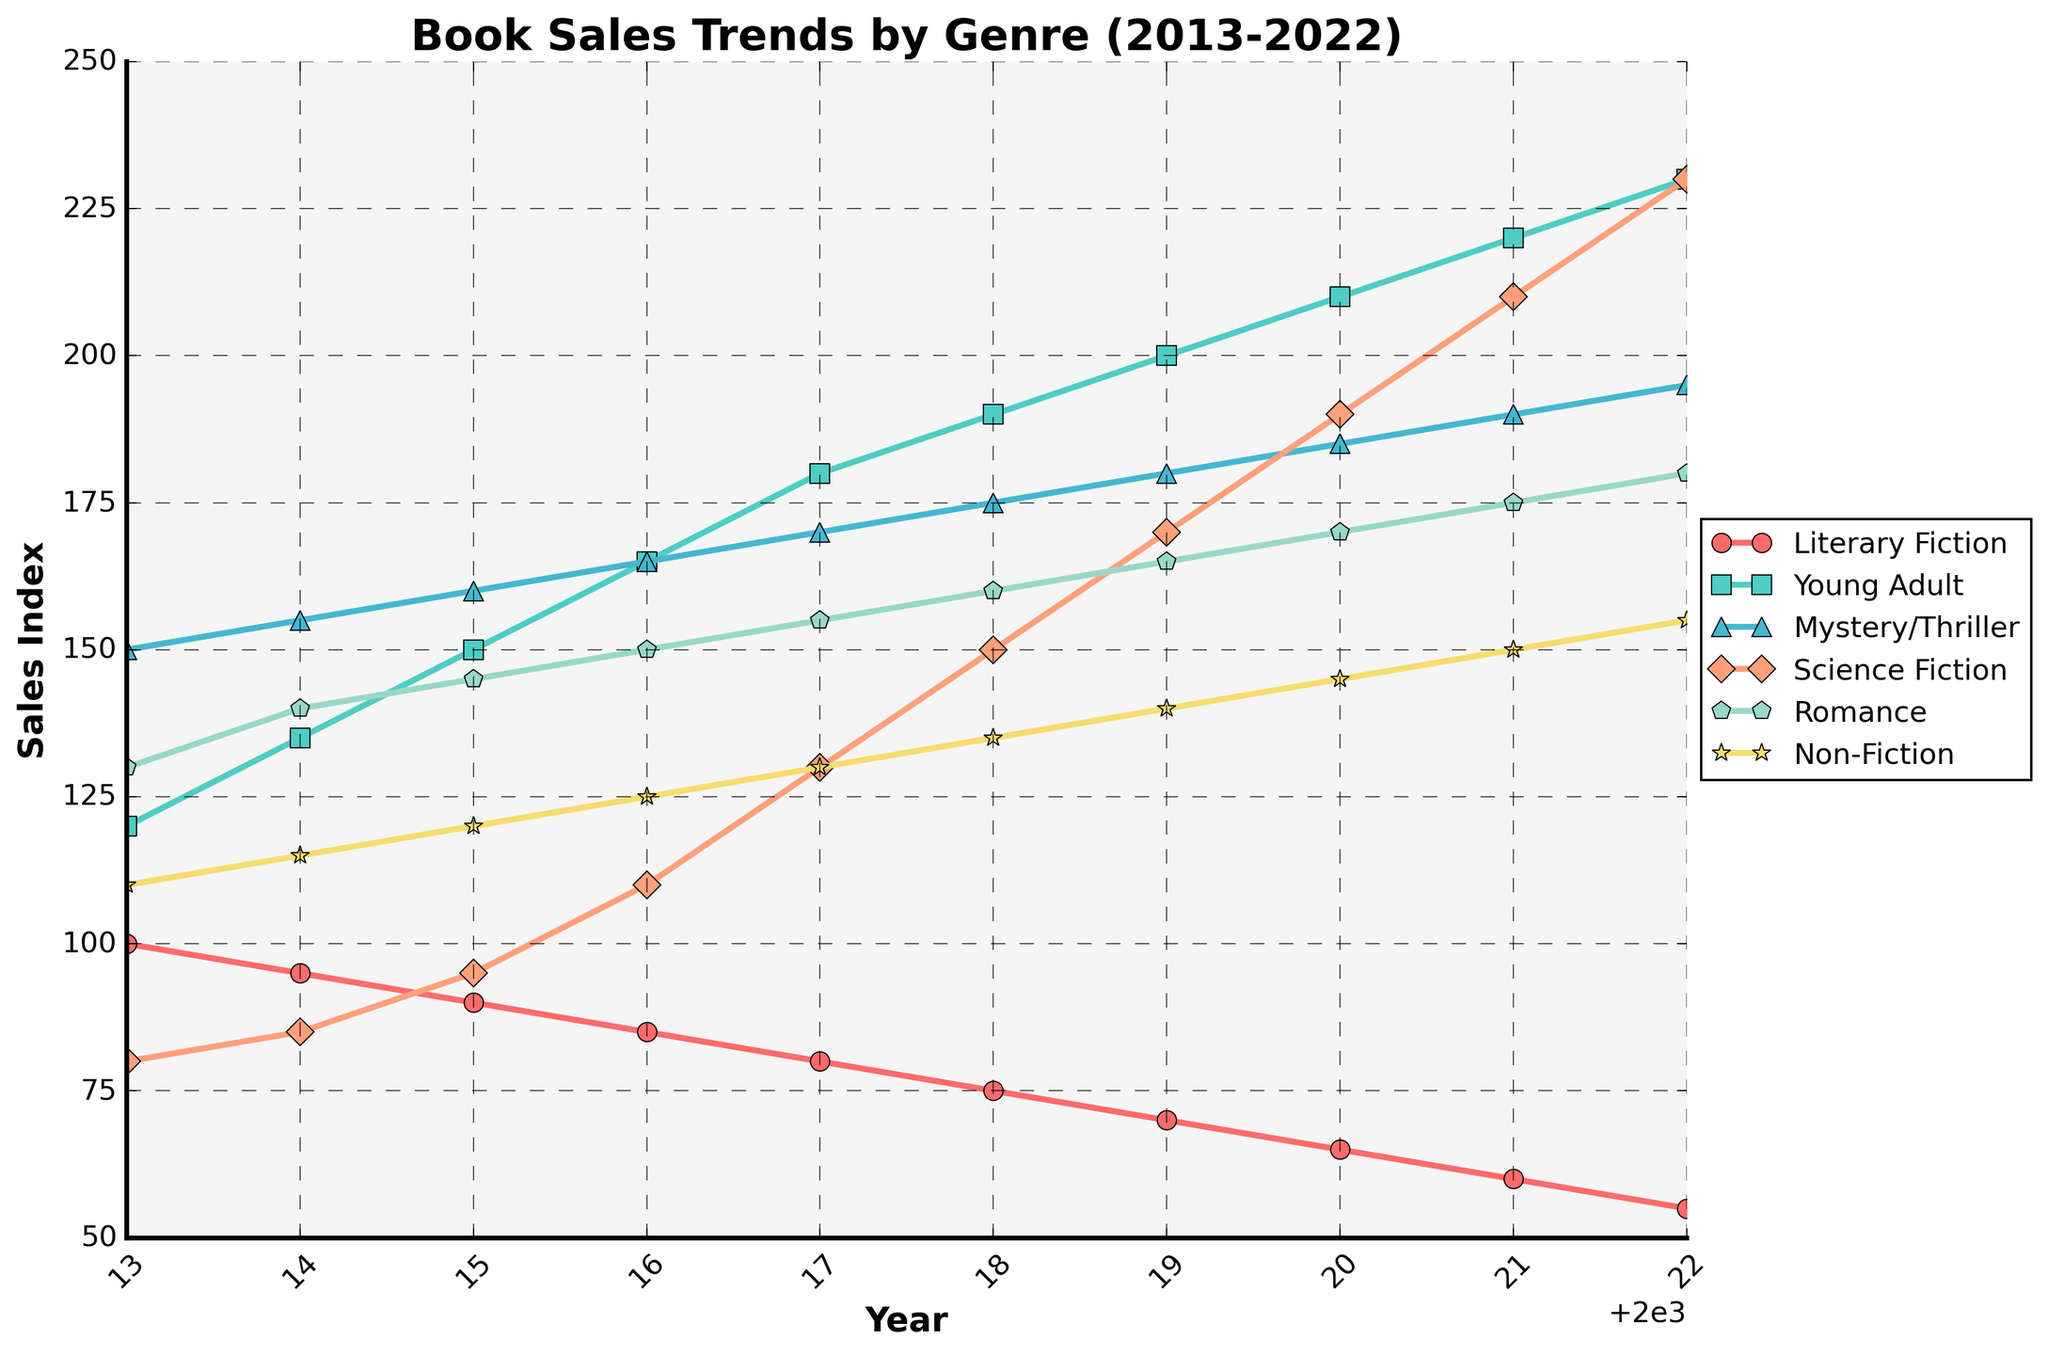What is the genre with the highest sales in 2022? To find the genre with the highest sales in 2022, look for the data point with the highest value on the y-axis for the year 2022. The highest point in 2022 is at the top of the scale for the Young Adult genre.
Answer: Young Adult Which genre experienced the largest increase in sales from 2013 to 2022? To determine the largest increase, subtract the 2013 sales value from the 2022 sales value for each genre and compare. The difference for each genre is: Literary Fiction (-45), Young Adult (+110), Mystery/Thriller (+45), Science Fiction (+150), Romance (+50), Non-Fiction (+45). The largest increase is in Science Fiction.
Answer: Science Fiction How did the sales of Literary Fiction change from 2013 to 2022? Observe the sales value for Literary Fiction in 2013 (100) and in 2022 (55). Calculate the difference to find the change: 100 - 55 = -45.
Answer: Decreased by 45 What was the total sales value for Romance and Non-Fiction in 2022? Add the sales values for Romance (180) and Non-Fiction (155) in 2022. The sum is: 180 + 155 = 335.
Answer: 335 Which genre had a sales value closest to 200 in 2016? Identify the sales values for each genre in 2016 and find which is closest to 200: Literary Fiction (85), Young Adult (165), Mystery/Thriller (165), Science Fiction (110), Romance (150), Non-Fiction (125). The closest value to 200 is by the Young Adult genre at 165.
Answer: Young Adult What is the overall trend in sales for Mystery/Thriller from 2013 to 2022? Observe the sales values of Mystery/Thriller from 2013 (150) to 2022 (195). The sales values generally increase every year, indicating an upward trend.
Answer: Upward trend Did Science Fiction sales ever surpass Non-Fiction sales within the given period? Compare the sales values of Science Fiction and Non-Fiction for each year. From 2018 onwards, Science Fiction sales are consistently higher than Non-Fiction sales.
Answer: Yes What is the average sales value of Young Adult genre over the decade? Sum the sales values for Young Adult over the years: (120 + 135 + 150 + 165 + 180 + 190 + 200 + 210 + 220 + 230) = 1800. The average is calculated by dividing by the number of years (10): 1800 / 10 = 180.
Answer: 180 In which year did Romance sales surpass Science Fiction sales for the first time? Compare the sales values of Romance and Science Fiction year by year. In 2016, Romance (150) surpassed Science Fiction (110) for the first time.
Answer: 2016 By how much did the sales of Mystery/Thriller exceed Non-Fiction sales in 2020? Subtract the Non-Fiction sales value (145) from the Mystery/Thriller sales value (185) in 2020: 185 - 145 = 40.
Answer: 40 